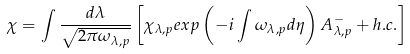<formula> <loc_0><loc_0><loc_500><loc_500>\chi = \int \frac { d \lambda } { \sqrt { 2 \pi \omega _ { \lambda , p } } } \left [ \chi _ { \lambda , p } e x p \left ( - i \int \omega _ { \lambda , p } d \eta \right ) A ^ { - } _ { \lambda , p } + h . c . \right ]</formula> 